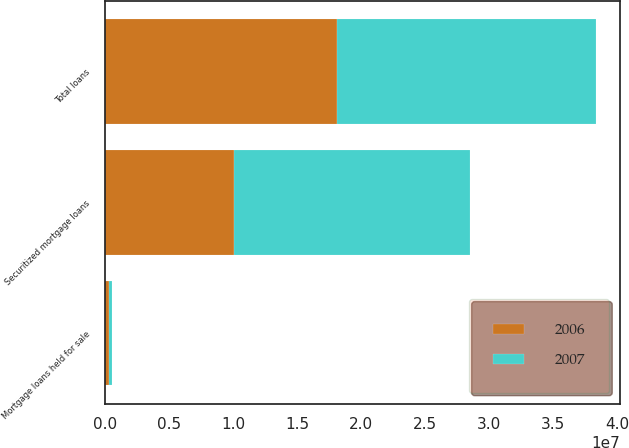<chart> <loc_0><loc_0><loc_500><loc_500><stacked_bar_chart><ecel><fcel>Securitized mortgage loans<fcel>Mortgage loans held for sale<fcel>Total loans<nl><fcel>2007<fcel>1.84349e+07<fcel>295208<fcel>2.01862e+07<nl><fcel>2006<fcel>1.0046e+07<fcel>255224<fcel>1.81471e+07<nl></chart> 